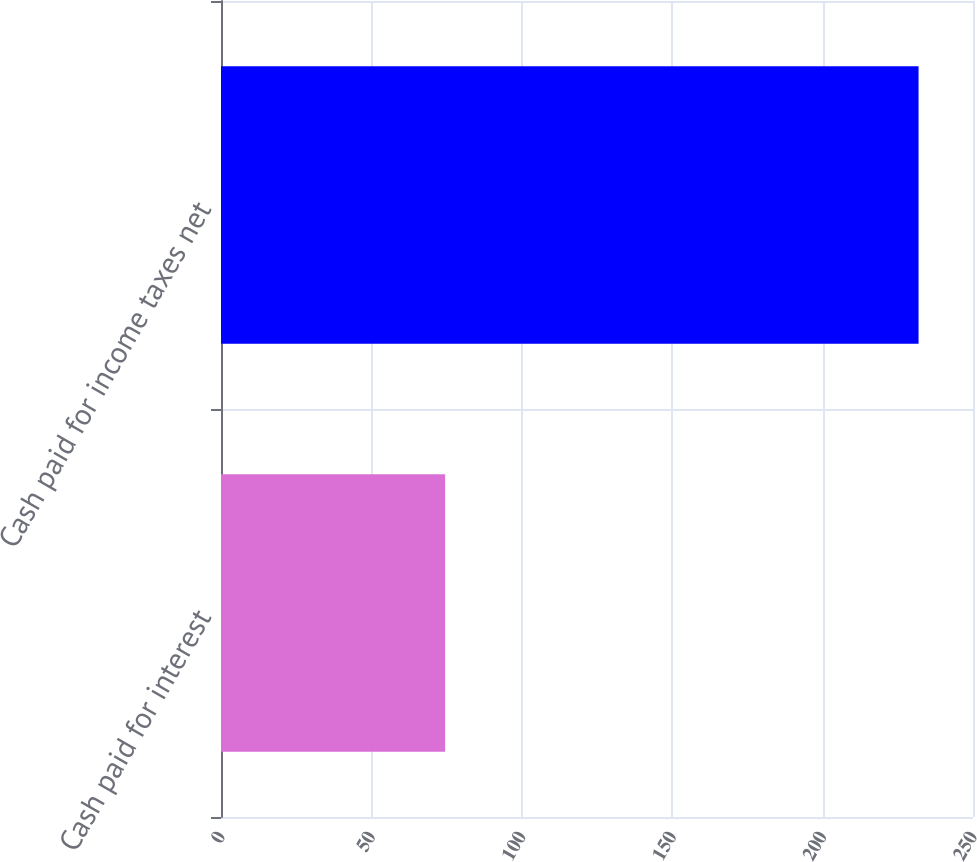<chart> <loc_0><loc_0><loc_500><loc_500><bar_chart><fcel>Cash paid for interest<fcel>Cash paid for income taxes net<nl><fcel>74.5<fcel>231.9<nl></chart> 